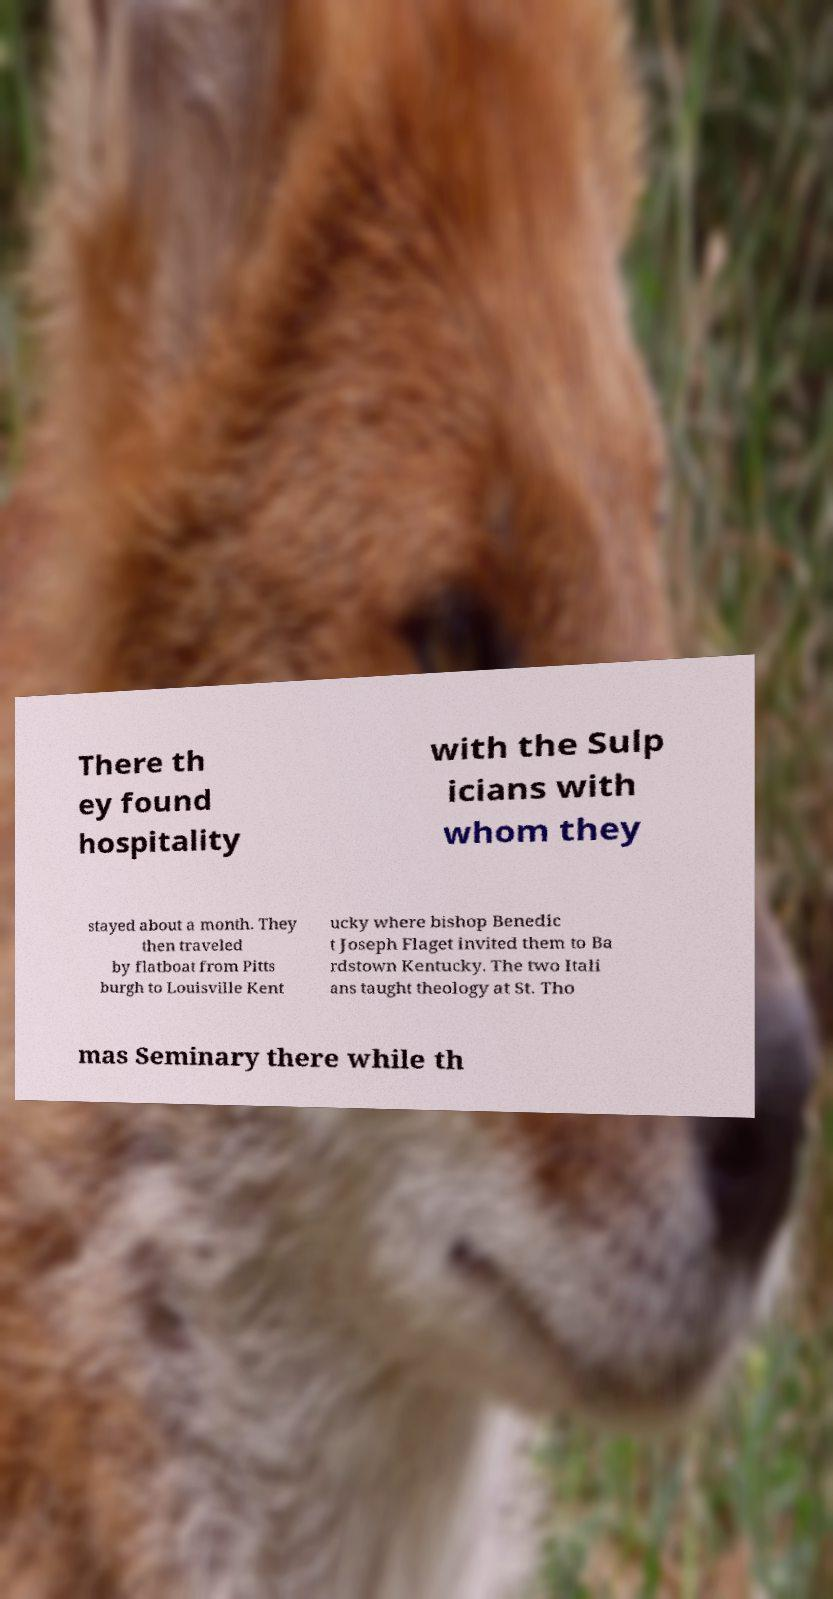Please read and relay the text visible in this image. What does it say? There th ey found hospitality with the Sulp icians with whom they stayed about a month. They then traveled by flatboat from Pitts burgh to Louisville Kent ucky where bishop Benedic t Joseph Flaget invited them to Ba rdstown Kentucky. The two Itali ans taught theology at St. Tho mas Seminary there while th 